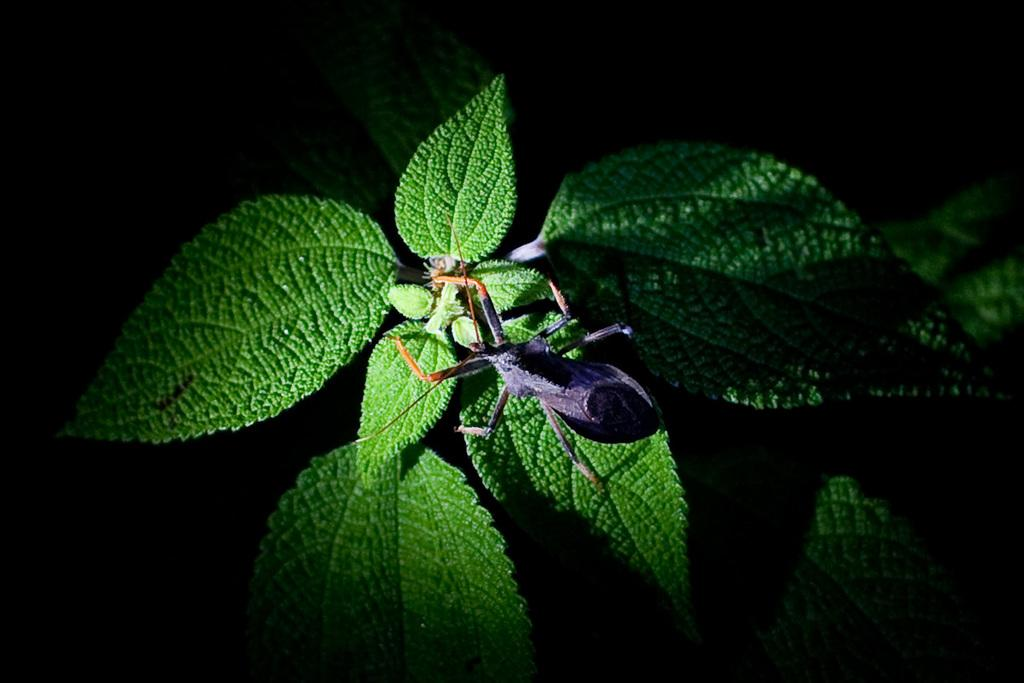What type of creature is in the image? There is an insect in the image. What colors can be seen on the insect? The insect has violet, black, and orange colors. Where is the insect located in the image? The insect is on a plant. What is the color of the plant? The plant is green in color. What can be observed about the background of the image? The background of the image is dark. What type of polish is being applied to the silverware in the image? There is no silverware or polish present in the image; it features an insect on a plant with a dark background. 